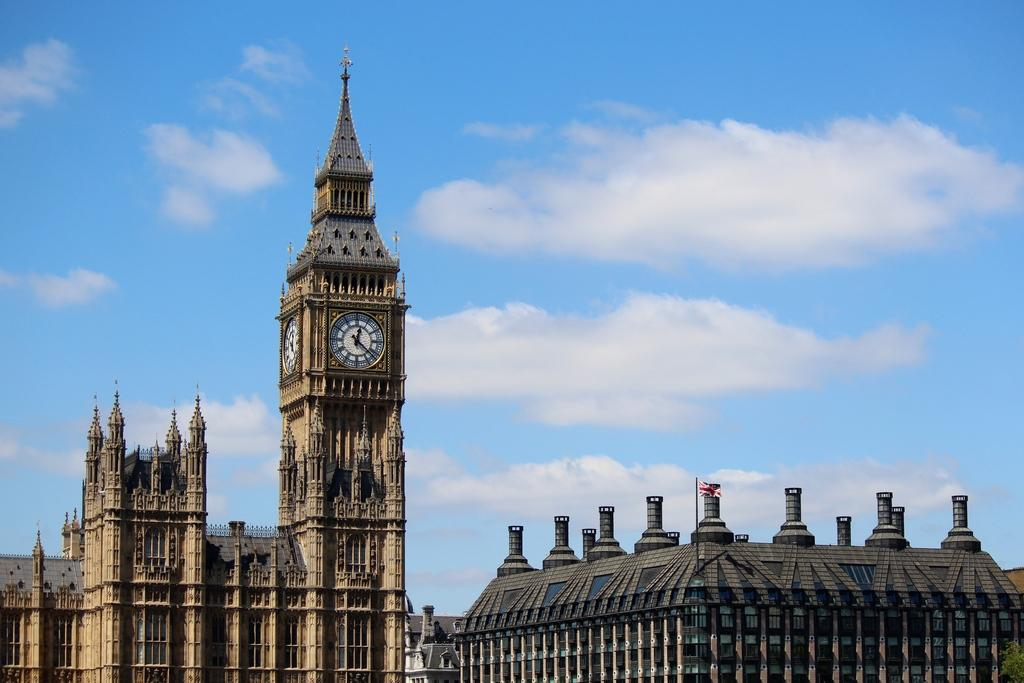What type of structures can be seen in the image? There are buildings in the image. What is located near the buildings? There is a flagpole in the image. What can be seen in the background of the image? The sky is visible in the background of the image, and clouds are present. What type of attraction is the brother holding in the image? There is no attraction or brother present in the image; it only features buildings, a flagpole, and the sky with clouds. 